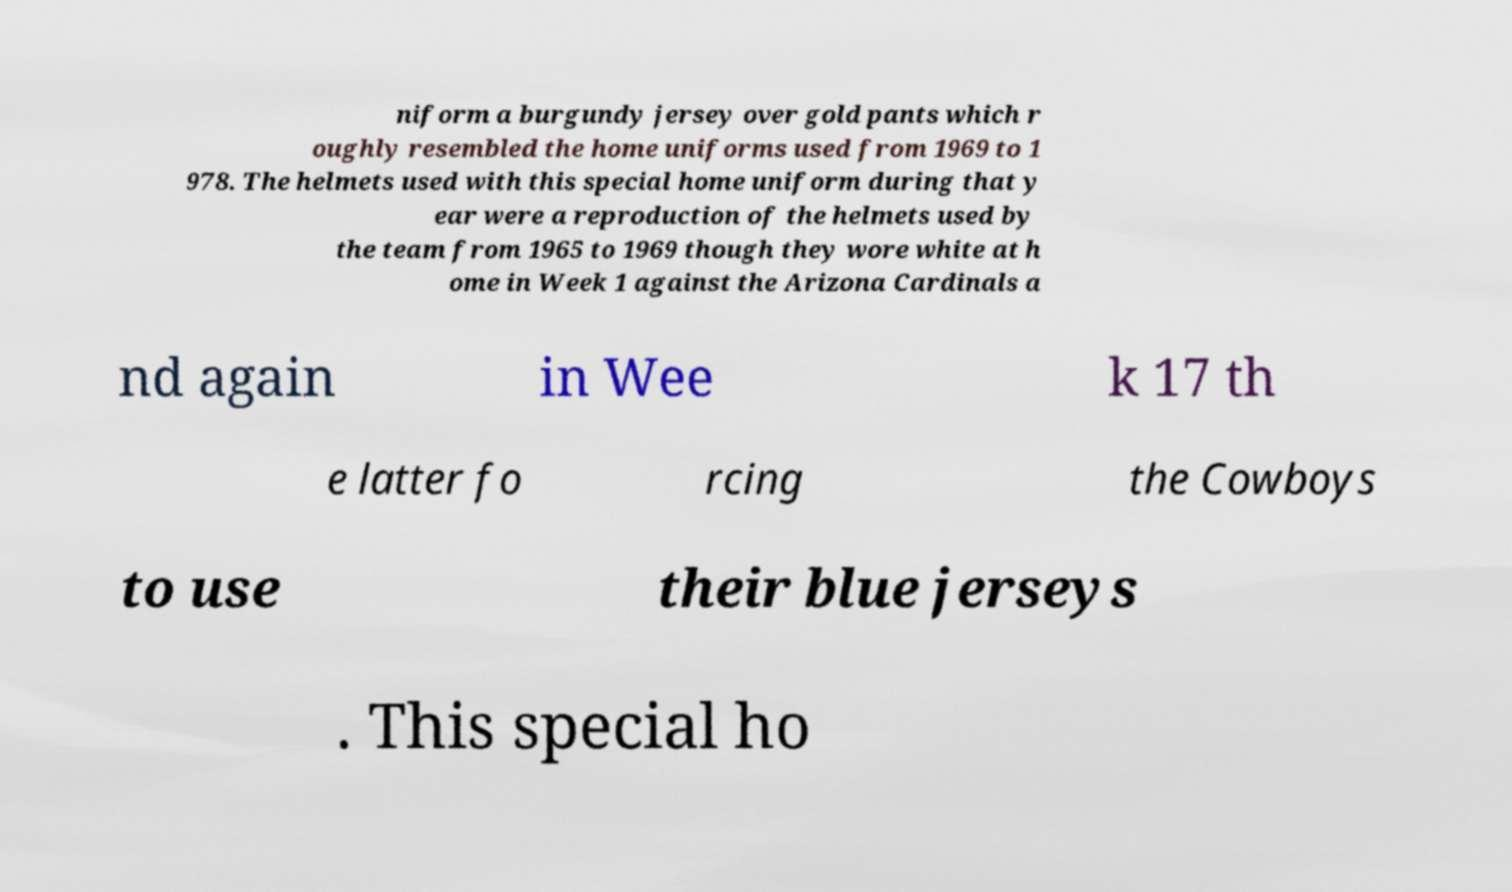Can you accurately transcribe the text from the provided image for me? niform a burgundy jersey over gold pants which r oughly resembled the home uniforms used from 1969 to 1 978. The helmets used with this special home uniform during that y ear were a reproduction of the helmets used by the team from 1965 to 1969 though they wore white at h ome in Week 1 against the Arizona Cardinals a nd again in Wee k 17 th e latter fo rcing the Cowboys to use their blue jerseys . This special ho 